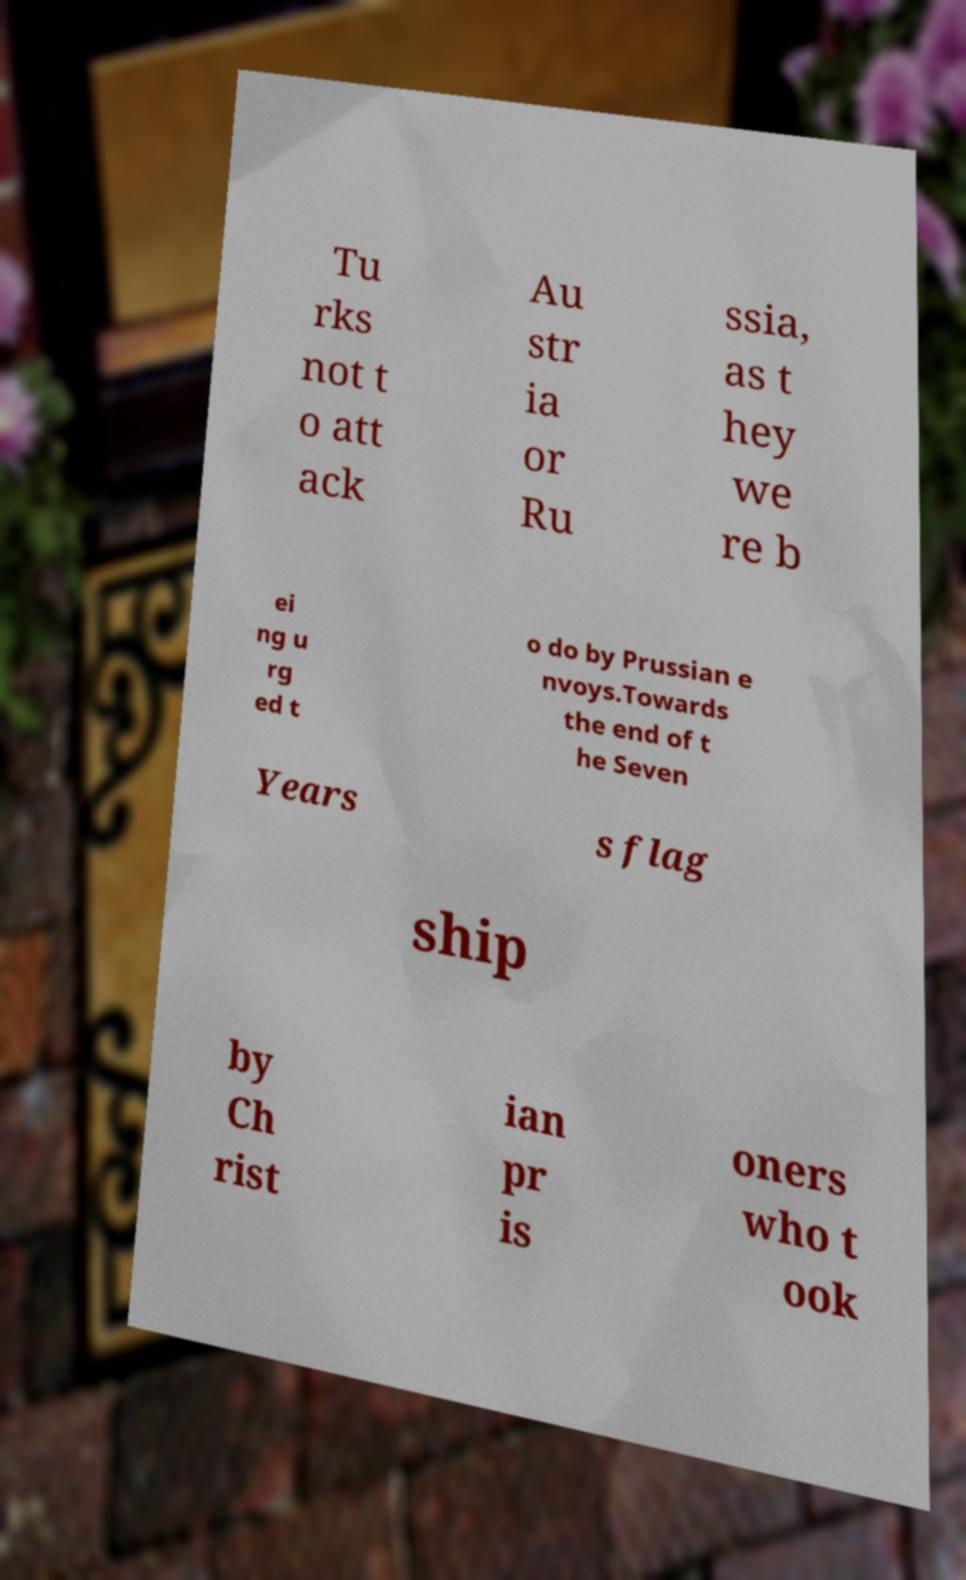Could you assist in decoding the text presented in this image and type it out clearly? Tu rks not t o att ack Au str ia or Ru ssia, as t hey we re b ei ng u rg ed t o do by Prussian e nvoys.Towards the end of t he Seven Years s flag ship by Ch rist ian pr is oners who t ook 